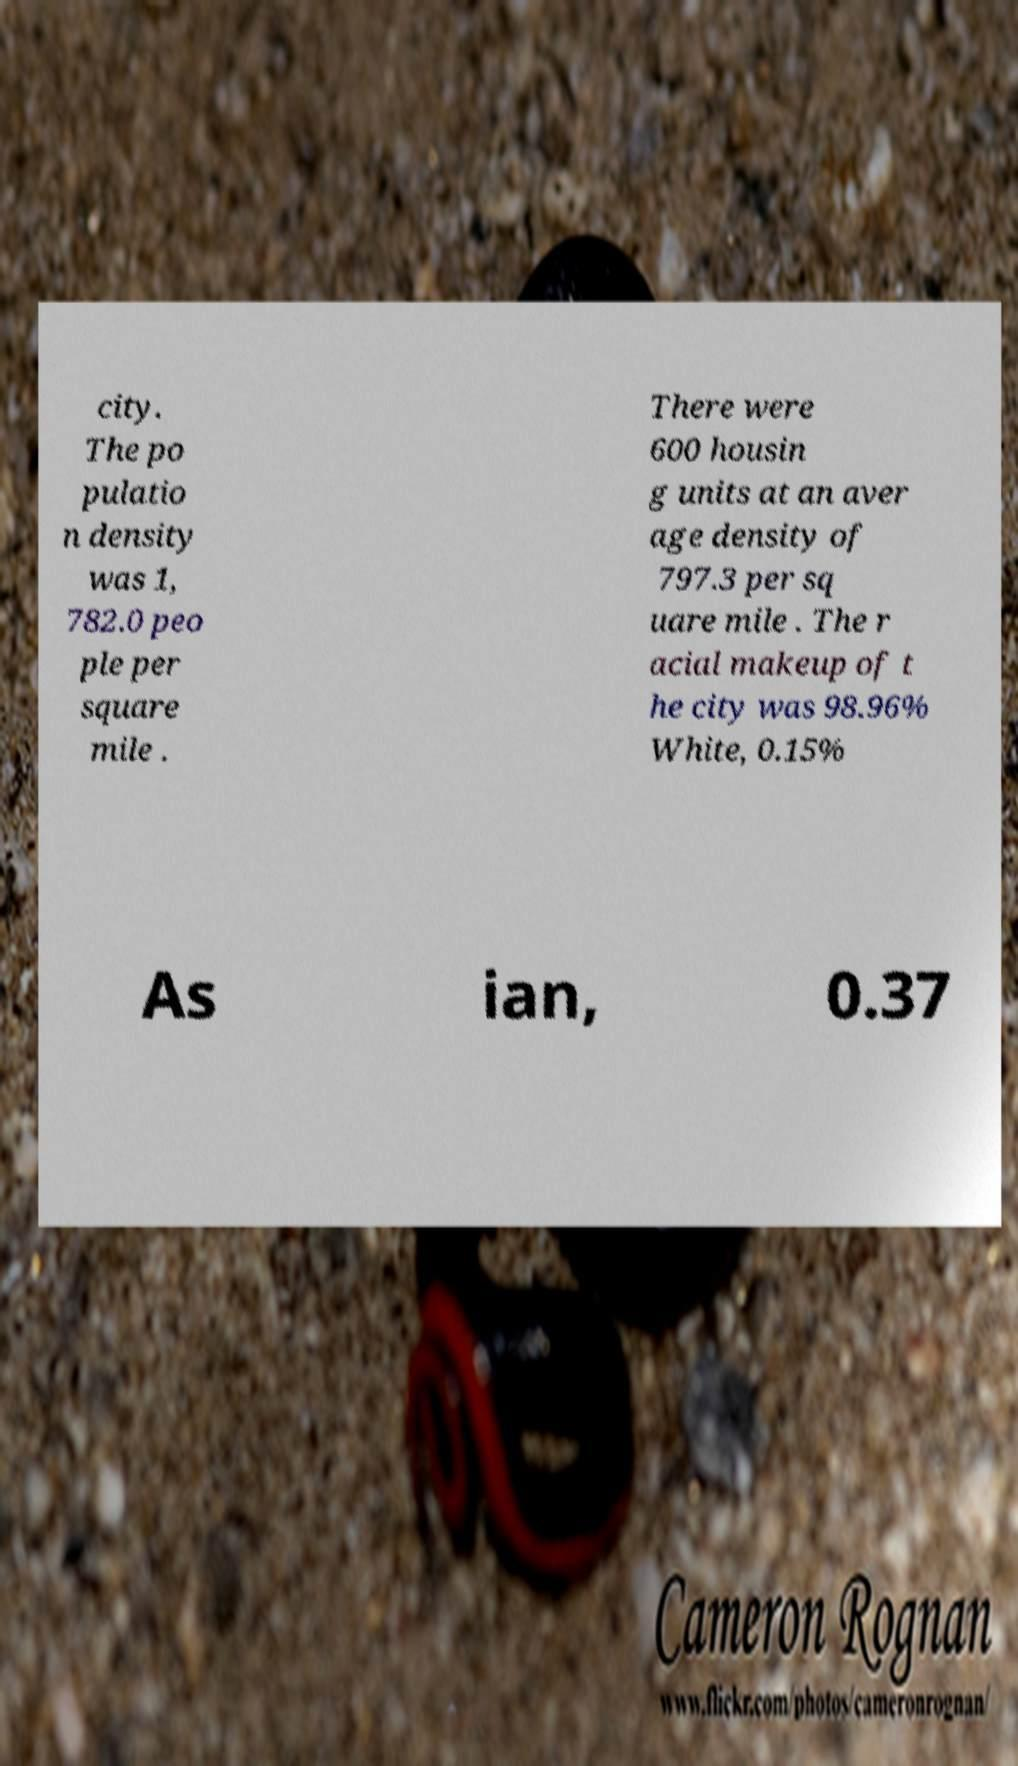I need the written content from this picture converted into text. Can you do that? city. The po pulatio n density was 1, 782.0 peo ple per square mile . There were 600 housin g units at an aver age density of 797.3 per sq uare mile . The r acial makeup of t he city was 98.96% White, 0.15% As ian, 0.37 